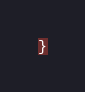<code> <loc_0><loc_0><loc_500><loc_500><_CSS_>}
</code> 